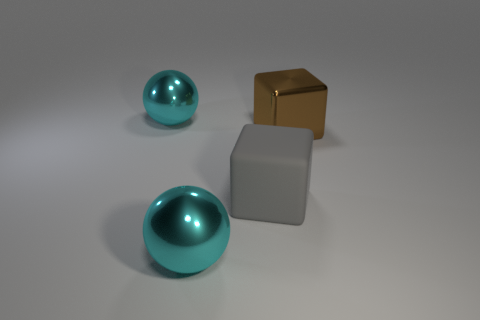How many other things are there of the same shape as the big gray matte thing?
Give a very brief answer. 1. There is a thing that is to the left of the big gray thing and in front of the metal cube; what color is it?
Offer a very short reply. Cyan. Is the material of the big thing to the right of the large gray rubber thing the same as the big gray object?
Offer a very short reply. No. Are there fewer big brown shiny objects that are in front of the gray rubber object than big green rubber cylinders?
Keep it short and to the point. No. Is there a object that has the same material as the large brown block?
Make the answer very short. Yes. Does the large brown thing have the same material as the large gray cube?
Ensure brevity in your answer.  No. What number of big rubber blocks are to the left of the shiny cube?
Provide a succinct answer. 1. What material is the large object that is both behind the large rubber thing and to the left of the brown block?
Offer a very short reply. Metal. What number of other gray cubes have the same size as the metal cube?
Give a very brief answer. 1. What is the color of the big metal ball behind the cube that is to the left of the brown shiny thing?
Keep it short and to the point. Cyan. 